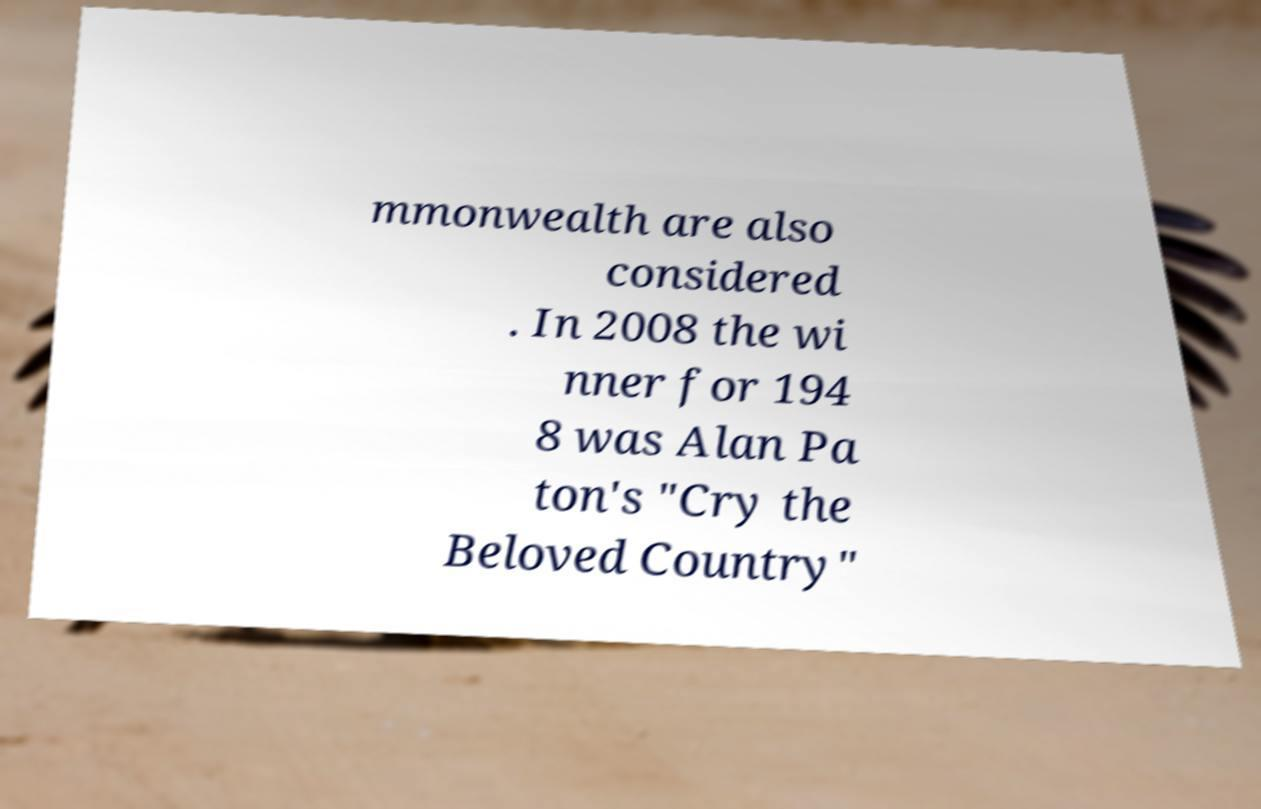Please identify and transcribe the text found in this image. mmonwealth are also considered . In 2008 the wi nner for 194 8 was Alan Pa ton's "Cry the Beloved Country" 